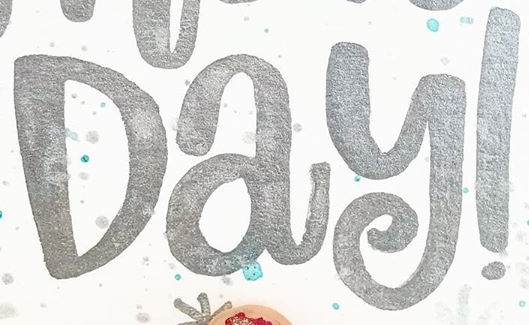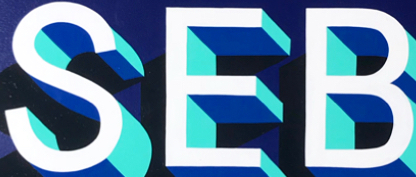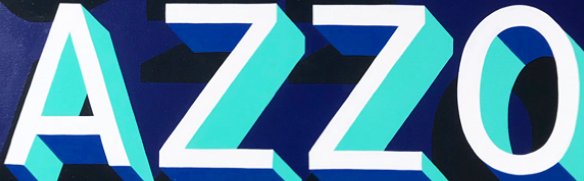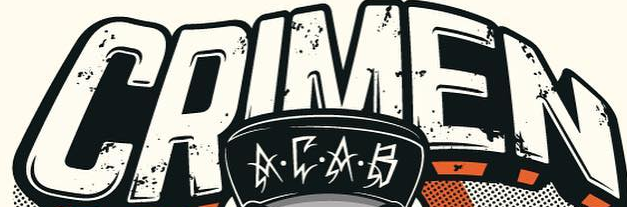Read the text content from these images in order, separated by a semicolon. Day!; SEB; AZZO; CRIMEN 